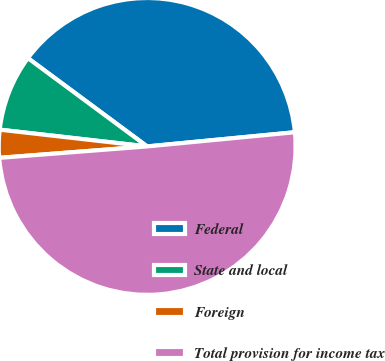Convert chart to OTSL. <chart><loc_0><loc_0><loc_500><loc_500><pie_chart><fcel>Federal<fcel>State and local<fcel>Foreign<fcel>Total provision for income tax<nl><fcel>38.33%<fcel>8.34%<fcel>3.03%<fcel>50.29%<nl></chart> 